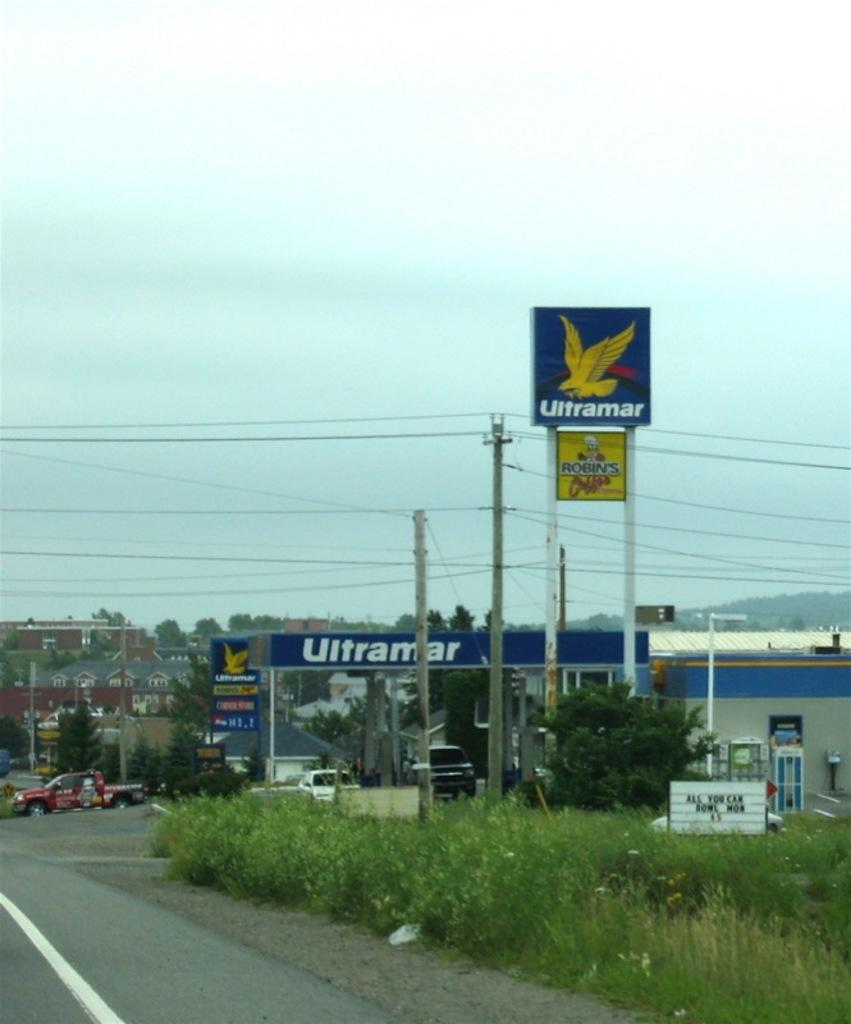<image>
Relay a brief, clear account of the picture shown. An Ultramar gas station sits along a roadway near a Robin's restaurant. 